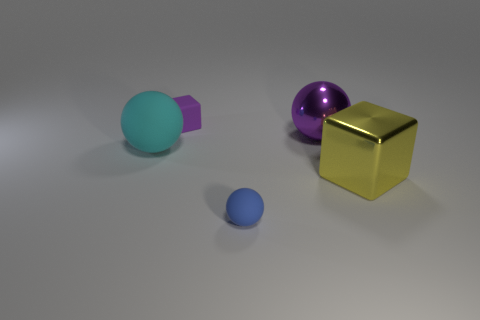Add 1 blue objects. How many objects exist? 6 Subtract all balls. How many objects are left? 2 Subtract 0 yellow cylinders. How many objects are left? 5 Subtract all cubes. Subtract all blue cubes. How many objects are left? 3 Add 3 big shiny cubes. How many big shiny cubes are left? 4 Add 5 small purple rubber blocks. How many small purple rubber blocks exist? 6 